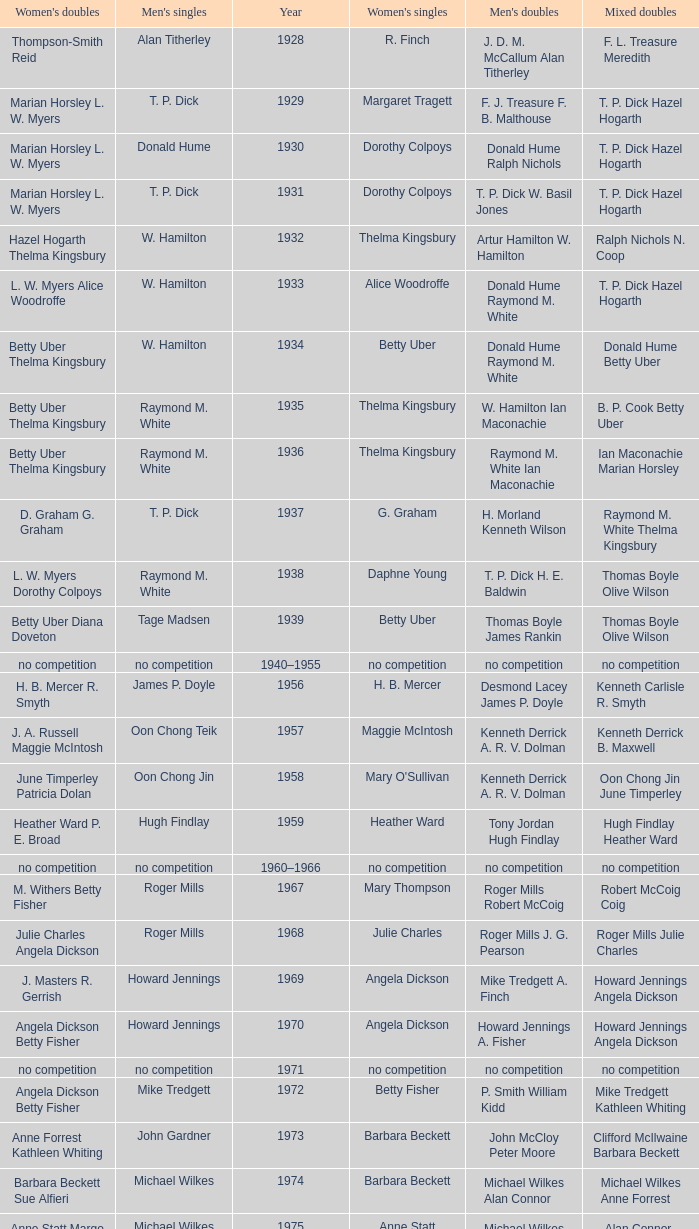Who won the Women's doubles in the year that Jesper Knudsen Nettie Nielsen won the Mixed doubles? Karen Beckman Sara Halsall. 